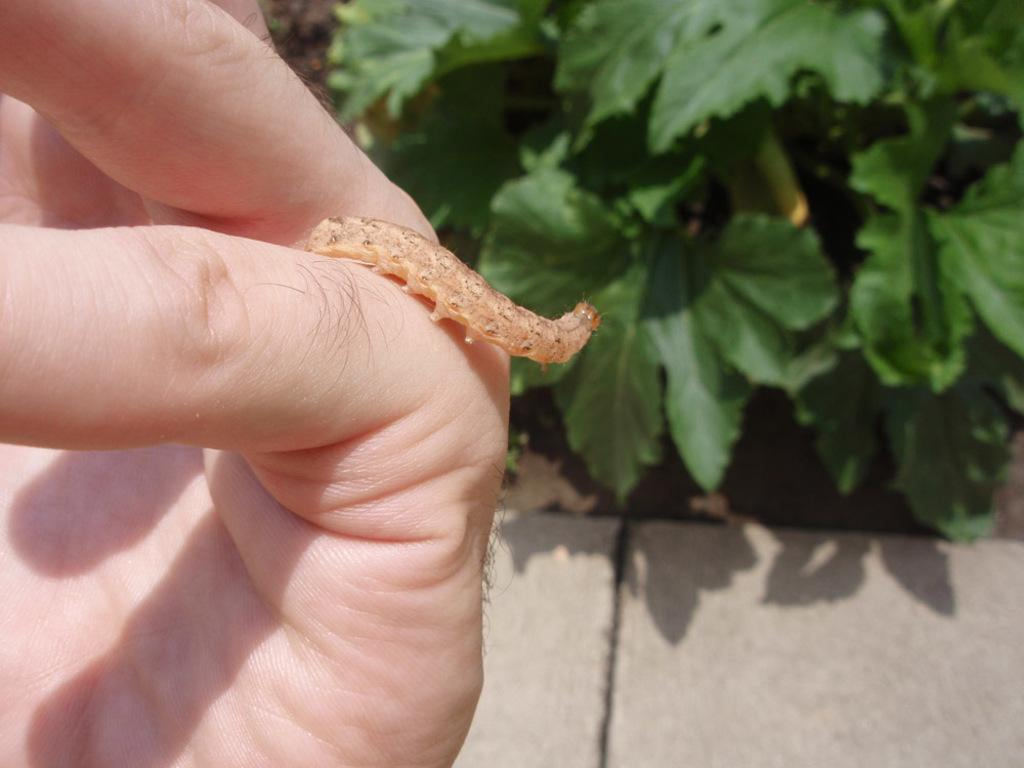What is on the person's hand in the image? There is an insect on the person's hand in the image. What can be seen in the background of the image? There are plants with leaves in the background of the image. What is visible at the bottom of the image? There appears to be a pathway at the bottom of the image. What time of day is it in the image, based on the position of the sun? The position of the sun is not visible in the image, so it is not possible to determine the time of day. 